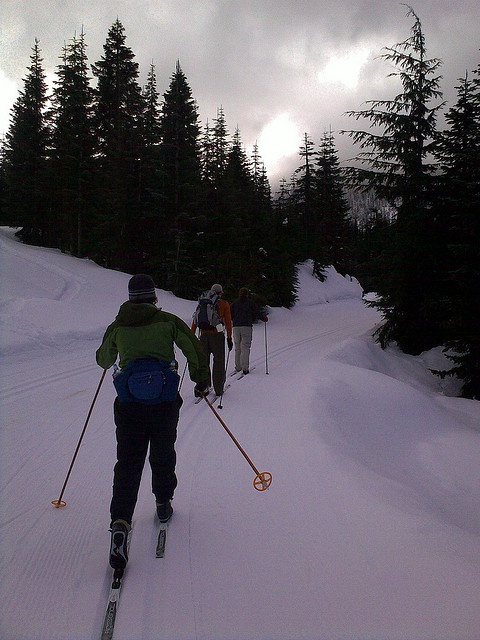Describe the objects in this image and their specific colors. I can see people in darkgray, black, and gray tones, people in darkgray, black, gray, and maroon tones, backpack in darkgray, black, navy, and gray tones, people in darkgray, black, and gray tones, and skis in darkgray, black, and gray tones in this image. 